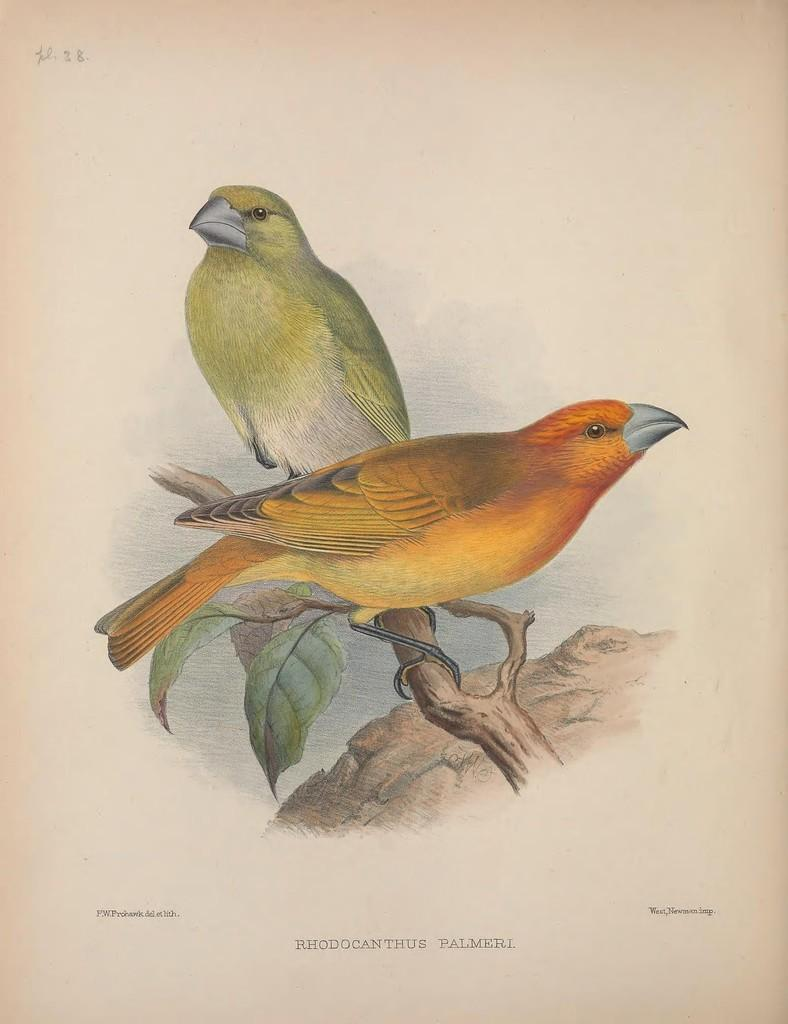What is the main subject of the image? The main subject of the image is a painting. What is depicted in the painting? The painting depicts two birds. Where are the birds located in the painting? The birds are on a branch in the painting. What type of stone is the painting painted on in the image? There is no information about the material the painting is painted on in the image. What emotion can be seen on the faces of the birds in the painting? The birds in the painting do not have faces, so it is not possible to determine their emotions. 